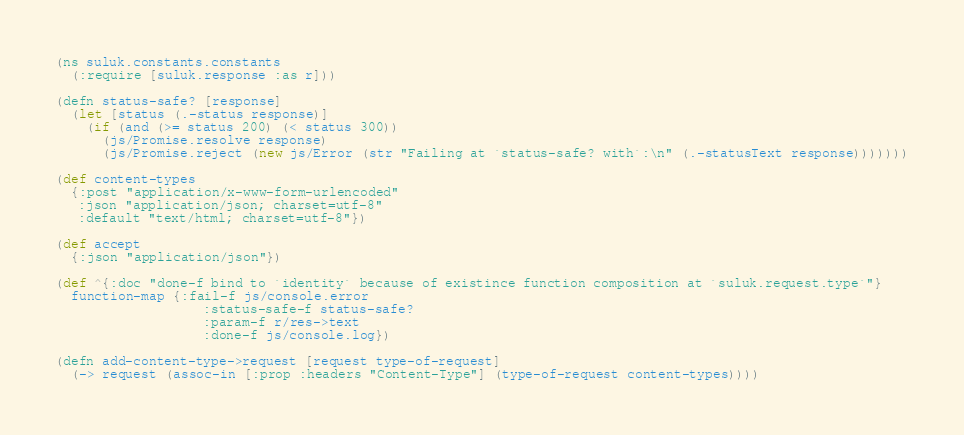<code> <loc_0><loc_0><loc_500><loc_500><_Clojure_>(ns suluk.constants.constants
  (:require [suluk.response :as r]))

(defn status-safe? [response]
  (let [status (.-status response)]
    (if (and (>= status 200) (< status 300))
      (js/Promise.resolve response)
      (js/Promise.reject (new js/Error (str "Failing at `status-safe? with`:\n" (.-statusText response)))))))

(def content-types
  {:post "application/x-www-form-urlencoded"
   :json "application/json; charset=utf-8"
   :default "text/html; charset=utf-8"})

(def accept
  {:json "application/json"})

(def ^{:doc "done-f bind to `identity` because of existince function composition at `suluk.request.type`"}
  function-map {:fail-f js/console.error
                   :status-safe-f status-safe?
                   :param-f r/res->text
                   :done-f js/console.log})

(defn add-content-type->request [request type-of-request]
  (-> request (assoc-in [:prop :headers "Content-Type"] (type-of-request content-types))))
</code> 